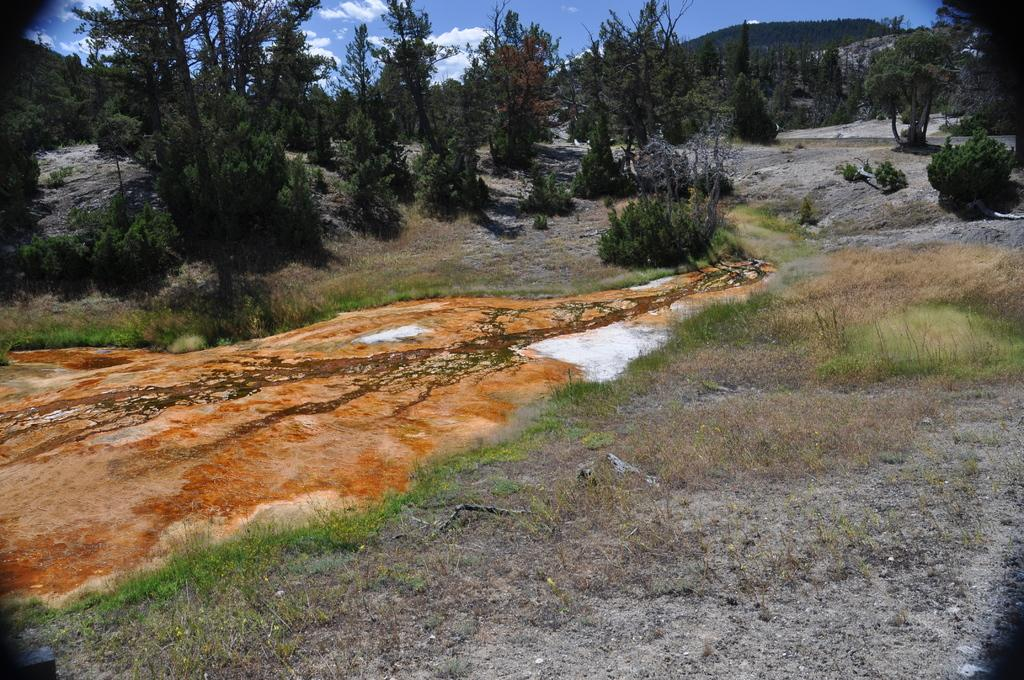What type of vegetation can be seen in the image? There are trees in the image. What is covering the ground in the image? There is grass on the ground in the image. What is the color of the soil in the center of the image? The ground has red soil in the center. What can be seen in the distance in the image? There are mountains in the background of the image. What is visible at the top of the image? The sky is visible at the top of the image. How many bikes are leaning against the trees in the image? There are no bikes present in the image; it features trees, grass, red soil, mountains, and the sky. What type of glue is being used to hold the mountains together in the image? There is no glue present in the image, and the mountains are not being held together by any substance. 